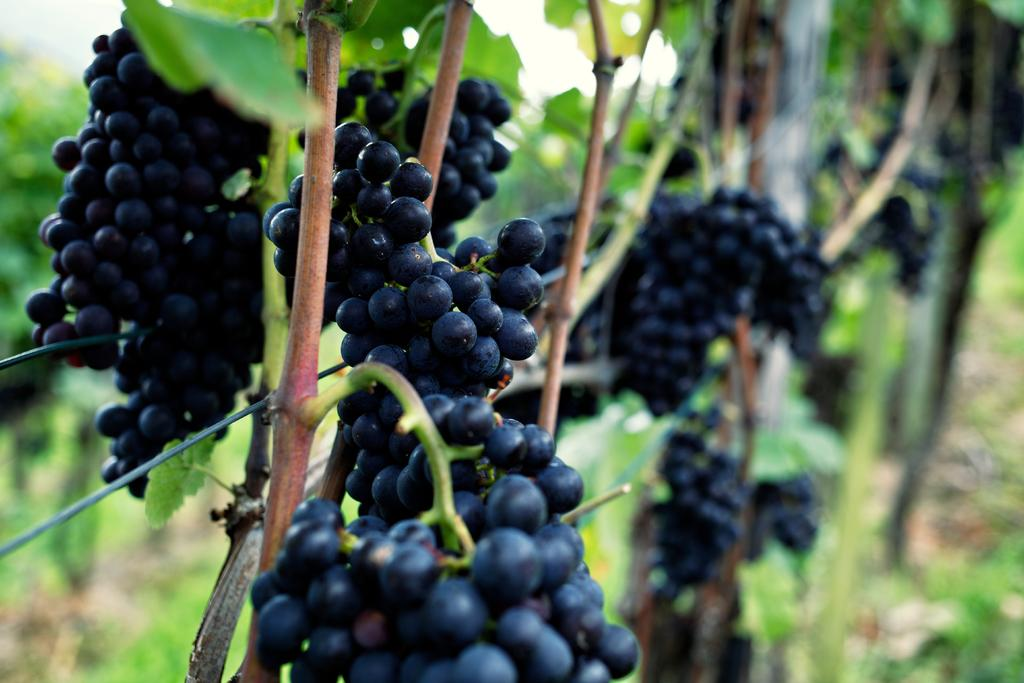What type of fruit can be seen in the image? There are bunches of grapes in the image. What type of vegetation is present in the image? There are trees in the image. Can you describe the background of the image? The background of the image is blurry. What type of fear can be seen on the faces of the horses in the image? There are no horses present in the image, so it is not possible to determine if they are experiencing any fear. 